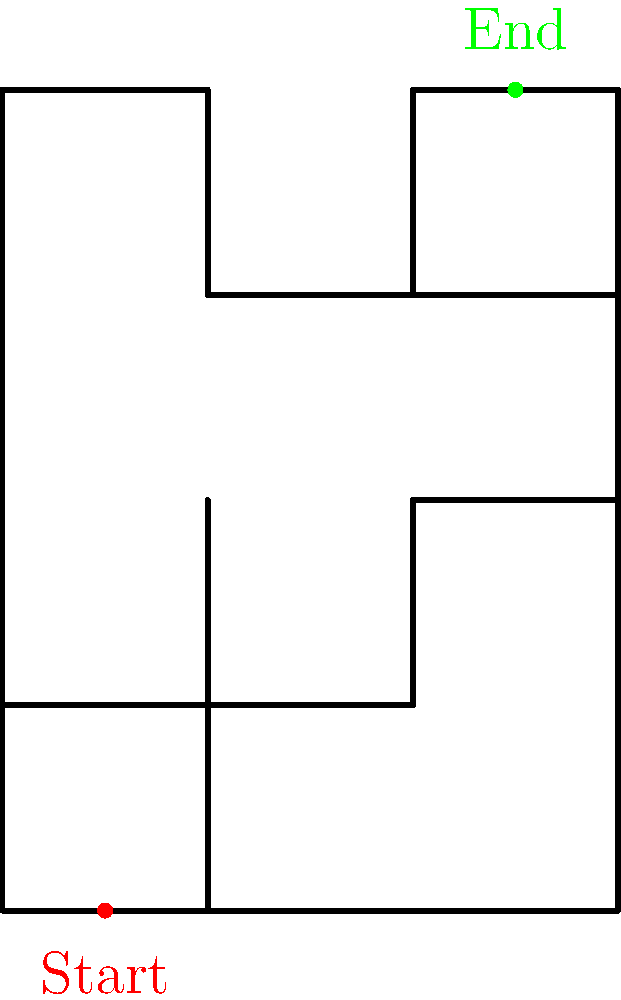As an expert in spatial intelligence, analyze the maze-like structure shown above. What is the minimum number of turns required to navigate from the start point (red dot) to the end point (green dot), assuming you can only move horizontally or vertically? To solve this problem, we need to trace the shortest path from the start to the end point, counting the number of turns:

1. Start at the red dot (0.5, 0).
2. Move up 1 unit (0.5, 1). No turn yet.
3. Turn right and move 1.5 units (2, 1). First turn.
4. Turn left and move up 1 unit (2, 2). Second turn.
5. Turn right and move 1 unit (3, 2). Third turn.
6. Turn left and move up 2 units to reach the green dot (3, 4). Fourth turn.

The path (0.5,0) -> (0.5,1) -> (2,1) -> (2,2) -> (3,2) -> (3,4) requires 4 turns in total.

There are no shortcuts or alternative paths that would require fewer turns while adhering to the rules of moving only horizontally or vertically.
Answer: 4 turns 